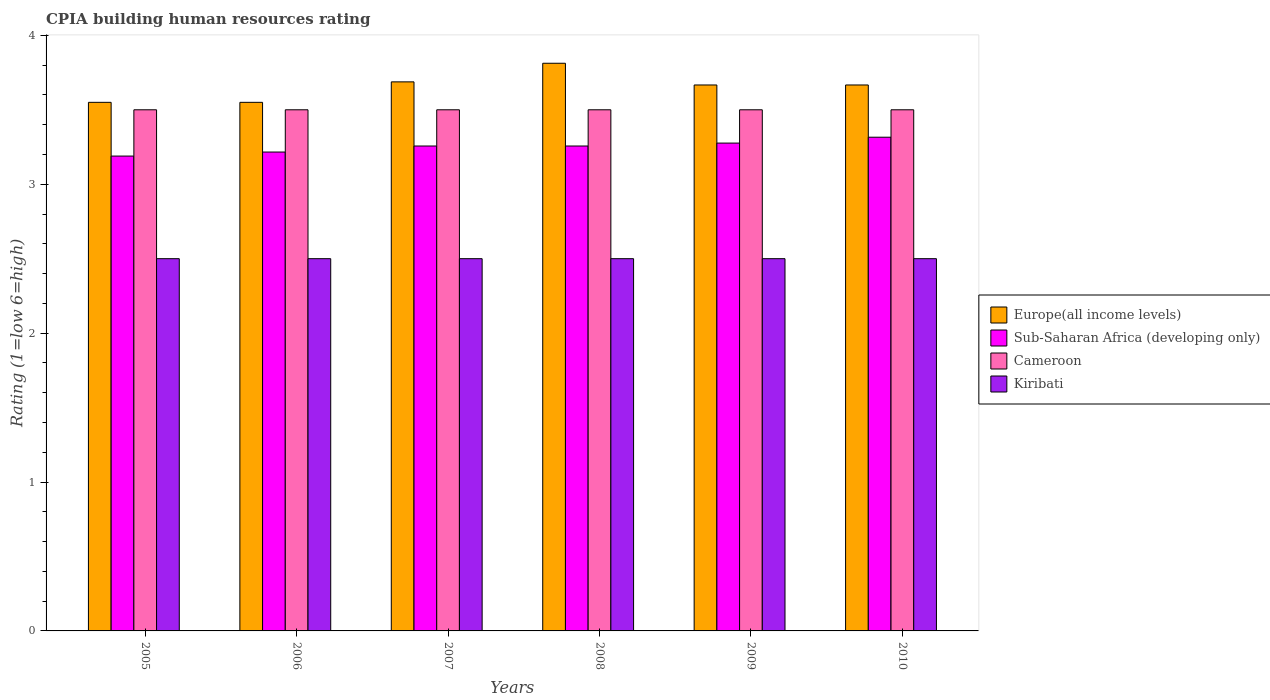How many groups of bars are there?
Give a very brief answer. 6. How many bars are there on the 1st tick from the left?
Your answer should be very brief. 4. What is the label of the 1st group of bars from the left?
Your answer should be compact. 2005. In how many cases, is the number of bars for a given year not equal to the number of legend labels?
Your answer should be compact. 0. Across all years, what is the maximum CPIA rating in Sub-Saharan Africa (developing only)?
Ensure brevity in your answer.  3.32. In which year was the CPIA rating in Europe(all income levels) minimum?
Keep it short and to the point. 2005. What is the total CPIA rating in Kiribati in the graph?
Give a very brief answer. 15. What is the difference between the CPIA rating in Kiribati in 2006 and that in 2007?
Provide a short and direct response. 0. What is the difference between the CPIA rating in Kiribati in 2008 and the CPIA rating in Sub-Saharan Africa (developing only) in 2007?
Your answer should be compact. -0.76. In the year 2008, what is the difference between the CPIA rating in Kiribati and CPIA rating in Sub-Saharan Africa (developing only)?
Your answer should be compact. -0.76. What is the ratio of the CPIA rating in Sub-Saharan Africa (developing only) in 2006 to that in 2007?
Ensure brevity in your answer.  0.99. Is the difference between the CPIA rating in Kiribati in 2006 and 2009 greater than the difference between the CPIA rating in Sub-Saharan Africa (developing only) in 2006 and 2009?
Provide a succinct answer. Yes. What is the difference between the highest and the second highest CPIA rating in Europe(all income levels)?
Your answer should be very brief. 0.12. What is the difference between the highest and the lowest CPIA rating in Europe(all income levels)?
Offer a very short reply. 0.26. Is the sum of the CPIA rating in Cameroon in 2008 and 2009 greater than the maximum CPIA rating in Europe(all income levels) across all years?
Offer a terse response. Yes. What does the 4th bar from the left in 2008 represents?
Make the answer very short. Kiribati. What does the 2nd bar from the right in 2008 represents?
Offer a very short reply. Cameroon. Is it the case that in every year, the sum of the CPIA rating in Europe(all income levels) and CPIA rating in Sub-Saharan Africa (developing only) is greater than the CPIA rating in Cameroon?
Provide a short and direct response. Yes. How many bars are there?
Your response must be concise. 24. Are all the bars in the graph horizontal?
Offer a terse response. No. How are the legend labels stacked?
Provide a short and direct response. Vertical. What is the title of the graph?
Offer a very short reply. CPIA building human resources rating. Does "Central African Republic" appear as one of the legend labels in the graph?
Offer a terse response. No. What is the label or title of the X-axis?
Provide a short and direct response. Years. What is the label or title of the Y-axis?
Offer a very short reply. Rating (1=low 6=high). What is the Rating (1=low 6=high) in Europe(all income levels) in 2005?
Ensure brevity in your answer.  3.55. What is the Rating (1=low 6=high) of Sub-Saharan Africa (developing only) in 2005?
Offer a very short reply. 3.19. What is the Rating (1=low 6=high) of Cameroon in 2005?
Your response must be concise. 3.5. What is the Rating (1=low 6=high) in Kiribati in 2005?
Give a very brief answer. 2.5. What is the Rating (1=low 6=high) of Europe(all income levels) in 2006?
Offer a very short reply. 3.55. What is the Rating (1=low 6=high) in Sub-Saharan Africa (developing only) in 2006?
Your response must be concise. 3.22. What is the Rating (1=low 6=high) in Kiribati in 2006?
Offer a very short reply. 2.5. What is the Rating (1=low 6=high) of Europe(all income levels) in 2007?
Your response must be concise. 3.69. What is the Rating (1=low 6=high) of Sub-Saharan Africa (developing only) in 2007?
Keep it short and to the point. 3.26. What is the Rating (1=low 6=high) of Europe(all income levels) in 2008?
Provide a succinct answer. 3.81. What is the Rating (1=low 6=high) in Sub-Saharan Africa (developing only) in 2008?
Your answer should be compact. 3.26. What is the Rating (1=low 6=high) in Europe(all income levels) in 2009?
Ensure brevity in your answer.  3.67. What is the Rating (1=low 6=high) in Sub-Saharan Africa (developing only) in 2009?
Your answer should be very brief. 3.28. What is the Rating (1=low 6=high) of Cameroon in 2009?
Your answer should be compact. 3.5. What is the Rating (1=low 6=high) of Europe(all income levels) in 2010?
Your answer should be compact. 3.67. What is the Rating (1=low 6=high) in Sub-Saharan Africa (developing only) in 2010?
Your answer should be compact. 3.32. Across all years, what is the maximum Rating (1=low 6=high) in Europe(all income levels)?
Your response must be concise. 3.81. Across all years, what is the maximum Rating (1=low 6=high) of Sub-Saharan Africa (developing only)?
Your response must be concise. 3.32. Across all years, what is the minimum Rating (1=low 6=high) in Europe(all income levels)?
Provide a succinct answer. 3.55. Across all years, what is the minimum Rating (1=low 6=high) of Sub-Saharan Africa (developing only)?
Your response must be concise. 3.19. Across all years, what is the minimum Rating (1=low 6=high) in Cameroon?
Ensure brevity in your answer.  3.5. What is the total Rating (1=low 6=high) in Europe(all income levels) in the graph?
Ensure brevity in your answer.  21.93. What is the total Rating (1=low 6=high) of Sub-Saharan Africa (developing only) in the graph?
Offer a very short reply. 19.51. What is the total Rating (1=low 6=high) in Cameroon in the graph?
Offer a terse response. 21. What is the difference between the Rating (1=low 6=high) in Europe(all income levels) in 2005 and that in 2006?
Offer a very short reply. 0. What is the difference between the Rating (1=low 6=high) of Sub-Saharan Africa (developing only) in 2005 and that in 2006?
Provide a succinct answer. -0.03. What is the difference between the Rating (1=low 6=high) of Kiribati in 2005 and that in 2006?
Provide a short and direct response. 0. What is the difference between the Rating (1=low 6=high) of Europe(all income levels) in 2005 and that in 2007?
Your answer should be very brief. -0.14. What is the difference between the Rating (1=low 6=high) in Sub-Saharan Africa (developing only) in 2005 and that in 2007?
Offer a very short reply. -0.07. What is the difference between the Rating (1=low 6=high) in Europe(all income levels) in 2005 and that in 2008?
Ensure brevity in your answer.  -0.26. What is the difference between the Rating (1=low 6=high) in Sub-Saharan Africa (developing only) in 2005 and that in 2008?
Ensure brevity in your answer.  -0.07. What is the difference between the Rating (1=low 6=high) of Cameroon in 2005 and that in 2008?
Provide a succinct answer. 0. What is the difference between the Rating (1=low 6=high) in Europe(all income levels) in 2005 and that in 2009?
Offer a very short reply. -0.12. What is the difference between the Rating (1=low 6=high) of Sub-Saharan Africa (developing only) in 2005 and that in 2009?
Give a very brief answer. -0.09. What is the difference between the Rating (1=low 6=high) of Cameroon in 2005 and that in 2009?
Your answer should be very brief. 0. What is the difference between the Rating (1=low 6=high) of Europe(all income levels) in 2005 and that in 2010?
Offer a very short reply. -0.12. What is the difference between the Rating (1=low 6=high) in Sub-Saharan Africa (developing only) in 2005 and that in 2010?
Give a very brief answer. -0.13. What is the difference between the Rating (1=low 6=high) of Europe(all income levels) in 2006 and that in 2007?
Your answer should be compact. -0.14. What is the difference between the Rating (1=low 6=high) in Sub-Saharan Africa (developing only) in 2006 and that in 2007?
Make the answer very short. -0.04. What is the difference between the Rating (1=low 6=high) of Europe(all income levels) in 2006 and that in 2008?
Provide a short and direct response. -0.26. What is the difference between the Rating (1=low 6=high) in Sub-Saharan Africa (developing only) in 2006 and that in 2008?
Make the answer very short. -0.04. What is the difference between the Rating (1=low 6=high) in Cameroon in 2006 and that in 2008?
Make the answer very short. 0. What is the difference between the Rating (1=low 6=high) of Kiribati in 2006 and that in 2008?
Your answer should be compact. 0. What is the difference between the Rating (1=low 6=high) in Europe(all income levels) in 2006 and that in 2009?
Keep it short and to the point. -0.12. What is the difference between the Rating (1=low 6=high) of Sub-Saharan Africa (developing only) in 2006 and that in 2009?
Your answer should be compact. -0.06. What is the difference between the Rating (1=low 6=high) of Cameroon in 2006 and that in 2009?
Your response must be concise. 0. What is the difference between the Rating (1=low 6=high) in Kiribati in 2006 and that in 2009?
Keep it short and to the point. 0. What is the difference between the Rating (1=low 6=high) of Europe(all income levels) in 2006 and that in 2010?
Offer a terse response. -0.12. What is the difference between the Rating (1=low 6=high) of Sub-Saharan Africa (developing only) in 2006 and that in 2010?
Ensure brevity in your answer.  -0.1. What is the difference between the Rating (1=low 6=high) in Europe(all income levels) in 2007 and that in 2008?
Make the answer very short. -0.12. What is the difference between the Rating (1=low 6=high) in Cameroon in 2007 and that in 2008?
Provide a succinct answer. 0. What is the difference between the Rating (1=low 6=high) of Kiribati in 2007 and that in 2008?
Your response must be concise. 0. What is the difference between the Rating (1=low 6=high) of Europe(all income levels) in 2007 and that in 2009?
Offer a terse response. 0.02. What is the difference between the Rating (1=low 6=high) in Sub-Saharan Africa (developing only) in 2007 and that in 2009?
Your response must be concise. -0.02. What is the difference between the Rating (1=low 6=high) of Cameroon in 2007 and that in 2009?
Your answer should be very brief. 0. What is the difference between the Rating (1=low 6=high) in Europe(all income levels) in 2007 and that in 2010?
Ensure brevity in your answer.  0.02. What is the difference between the Rating (1=low 6=high) in Sub-Saharan Africa (developing only) in 2007 and that in 2010?
Give a very brief answer. -0.06. What is the difference between the Rating (1=low 6=high) in Kiribati in 2007 and that in 2010?
Provide a short and direct response. 0. What is the difference between the Rating (1=low 6=high) in Europe(all income levels) in 2008 and that in 2009?
Provide a succinct answer. 0.15. What is the difference between the Rating (1=low 6=high) in Sub-Saharan Africa (developing only) in 2008 and that in 2009?
Provide a succinct answer. -0.02. What is the difference between the Rating (1=low 6=high) in Kiribati in 2008 and that in 2009?
Your answer should be very brief. 0. What is the difference between the Rating (1=low 6=high) of Europe(all income levels) in 2008 and that in 2010?
Ensure brevity in your answer.  0.15. What is the difference between the Rating (1=low 6=high) of Sub-Saharan Africa (developing only) in 2008 and that in 2010?
Offer a terse response. -0.06. What is the difference between the Rating (1=low 6=high) in Kiribati in 2008 and that in 2010?
Offer a very short reply. 0. What is the difference between the Rating (1=low 6=high) in Europe(all income levels) in 2009 and that in 2010?
Give a very brief answer. 0. What is the difference between the Rating (1=low 6=high) of Sub-Saharan Africa (developing only) in 2009 and that in 2010?
Keep it short and to the point. -0.04. What is the difference between the Rating (1=low 6=high) of Cameroon in 2009 and that in 2010?
Your answer should be very brief. 0. What is the difference between the Rating (1=low 6=high) of Europe(all income levels) in 2005 and the Rating (1=low 6=high) of Sub-Saharan Africa (developing only) in 2006?
Give a very brief answer. 0.33. What is the difference between the Rating (1=low 6=high) in Europe(all income levels) in 2005 and the Rating (1=low 6=high) in Cameroon in 2006?
Your answer should be very brief. 0.05. What is the difference between the Rating (1=low 6=high) of Sub-Saharan Africa (developing only) in 2005 and the Rating (1=low 6=high) of Cameroon in 2006?
Your answer should be compact. -0.31. What is the difference between the Rating (1=low 6=high) of Sub-Saharan Africa (developing only) in 2005 and the Rating (1=low 6=high) of Kiribati in 2006?
Your answer should be very brief. 0.69. What is the difference between the Rating (1=low 6=high) of Europe(all income levels) in 2005 and the Rating (1=low 6=high) of Sub-Saharan Africa (developing only) in 2007?
Offer a very short reply. 0.29. What is the difference between the Rating (1=low 6=high) in Sub-Saharan Africa (developing only) in 2005 and the Rating (1=low 6=high) in Cameroon in 2007?
Your answer should be compact. -0.31. What is the difference between the Rating (1=low 6=high) in Sub-Saharan Africa (developing only) in 2005 and the Rating (1=low 6=high) in Kiribati in 2007?
Make the answer very short. 0.69. What is the difference between the Rating (1=low 6=high) of Cameroon in 2005 and the Rating (1=low 6=high) of Kiribati in 2007?
Make the answer very short. 1. What is the difference between the Rating (1=low 6=high) of Europe(all income levels) in 2005 and the Rating (1=low 6=high) of Sub-Saharan Africa (developing only) in 2008?
Give a very brief answer. 0.29. What is the difference between the Rating (1=low 6=high) in Europe(all income levels) in 2005 and the Rating (1=low 6=high) in Cameroon in 2008?
Offer a very short reply. 0.05. What is the difference between the Rating (1=low 6=high) of Sub-Saharan Africa (developing only) in 2005 and the Rating (1=low 6=high) of Cameroon in 2008?
Make the answer very short. -0.31. What is the difference between the Rating (1=low 6=high) of Sub-Saharan Africa (developing only) in 2005 and the Rating (1=low 6=high) of Kiribati in 2008?
Provide a succinct answer. 0.69. What is the difference between the Rating (1=low 6=high) of Cameroon in 2005 and the Rating (1=low 6=high) of Kiribati in 2008?
Give a very brief answer. 1. What is the difference between the Rating (1=low 6=high) in Europe(all income levels) in 2005 and the Rating (1=low 6=high) in Sub-Saharan Africa (developing only) in 2009?
Your answer should be very brief. 0.27. What is the difference between the Rating (1=low 6=high) of Europe(all income levels) in 2005 and the Rating (1=low 6=high) of Kiribati in 2009?
Provide a short and direct response. 1.05. What is the difference between the Rating (1=low 6=high) of Sub-Saharan Africa (developing only) in 2005 and the Rating (1=low 6=high) of Cameroon in 2009?
Offer a very short reply. -0.31. What is the difference between the Rating (1=low 6=high) in Sub-Saharan Africa (developing only) in 2005 and the Rating (1=low 6=high) in Kiribati in 2009?
Offer a terse response. 0.69. What is the difference between the Rating (1=low 6=high) of Cameroon in 2005 and the Rating (1=low 6=high) of Kiribati in 2009?
Ensure brevity in your answer.  1. What is the difference between the Rating (1=low 6=high) in Europe(all income levels) in 2005 and the Rating (1=low 6=high) in Sub-Saharan Africa (developing only) in 2010?
Make the answer very short. 0.23. What is the difference between the Rating (1=low 6=high) of Sub-Saharan Africa (developing only) in 2005 and the Rating (1=low 6=high) of Cameroon in 2010?
Ensure brevity in your answer.  -0.31. What is the difference between the Rating (1=low 6=high) of Sub-Saharan Africa (developing only) in 2005 and the Rating (1=low 6=high) of Kiribati in 2010?
Your response must be concise. 0.69. What is the difference between the Rating (1=low 6=high) of Europe(all income levels) in 2006 and the Rating (1=low 6=high) of Sub-Saharan Africa (developing only) in 2007?
Keep it short and to the point. 0.29. What is the difference between the Rating (1=low 6=high) in Europe(all income levels) in 2006 and the Rating (1=low 6=high) in Kiribati in 2007?
Your answer should be very brief. 1.05. What is the difference between the Rating (1=low 6=high) in Sub-Saharan Africa (developing only) in 2006 and the Rating (1=low 6=high) in Cameroon in 2007?
Offer a terse response. -0.28. What is the difference between the Rating (1=low 6=high) in Sub-Saharan Africa (developing only) in 2006 and the Rating (1=low 6=high) in Kiribati in 2007?
Your response must be concise. 0.72. What is the difference between the Rating (1=low 6=high) in Europe(all income levels) in 2006 and the Rating (1=low 6=high) in Sub-Saharan Africa (developing only) in 2008?
Your response must be concise. 0.29. What is the difference between the Rating (1=low 6=high) in Europe(all income levels) in 2006 and the Rating (1=low 6=high) in Cameroon in 2008?
Keep it short and to the point. 0.05. What is the difference between the Rating (1=low 6=high) in Europe(all income levels) in 2006 and the Rating (1=low 6=high) in Kiribati in 2008?
Provide a succinct answer. 1.05. What is the difference between the Rating (1=low 6=high) in Sub-Saharan Africa (developing only) in 2006 and the Rating (1=low 6=high) in Cameroon in 2008?
Provide a succinct answer. -0.28. What is the difference between the Rating (1=low 6=high) of Sub-Saharan Africa (developing only) in 2006 and the Rating (1=low 6=high) of Kiribati in 2008?
Offer a terse response. 0.72. What is the difference between the Rating (1=low 6=high) in Cameroon in 2006 and the Rating (1=low 6=high) in Kiribati in 2008?
Give a very brief answer. 1. What is the difference between the Rating (1=low 6=high) in Europe(all income levels) in 2006 and the Rating (1=low 6=high) in Sub-Saharan Africa (developing only) in 2009?
Your answer should be compact. 0.27. What is the difference between the Rating (1=low 6=high) of Sub-Saharan Africa (developing only) in 2006 and the Rating (1=low 6=high) of Cameroon in 2009?
Make the answer very short. -0.28. What is the difference between the Rating (1=low 6=high) of Sub-Saharan Africa (developing only) in 2006 and the Rating (1=low 6=high) of Kiribati in 2009?
Give a very brief answer. 0.72. What is the difference between the Rating (1=low 6=high) in Europe(all income levels) in 2006 and the Rating (1=low 6=high) in Sub-Saharan Africa (developing only) in 2010?
Your response must be concise. 0.23. What is the difference between the Rating (1=low 6=high) in Sub-Saharan Africa (developing only) in 2006 and the Rating (1=low 6=high) in Cameroon in 2010?
Offer a terse response. -0.28. What is the difference between the Rating (1=low 6=high) of Sub-Saharan Africa (developing only) in 2006 and the Rating (1=low 6=high) of Kiribati in 2010?
Your answer should be very brief. 0.72. What is the difference between the Rating (1=low 6=high) of Europe(all income levels) in 2007 and the Rating (1=low 6=high) of Sub-Saharan Africa (developing only) in 2008?
Make the answer very short. 0.43. What is the difference between the Rating (1=low 6=high) in Europe(all income levels) in 2007 and the Rating (1=low 6=high) in Cameroon in 2008?
Provide a short and direct response. 0.19. What is the difference between the Rating (1=low 6=high) of Europe(all income levels) in 2007 and the Rating (1=low 6=high) of Kiribati in 2008?
Ensure brevity in your answer.  1.19. What is the difference between the Rating (1=low 6=high) in Sub-Saharan Africa (developing only) in 2007 and the Rating (1=low 6=high) in Cameroon in 2008?
Ensure brevity in your answer.  -0.24. What is the difference between the Rating (1=low 6=high) of Sub-Saharan Africa (developing only) in 2007 and the Rating (1=low 6=high) of Kiribati in 2008?
Your answer should be very brief. 0.76. What is the difference between the Rating (1=low 6=high) in Europe(all income levels) in 2007 and the Rating (1=low 6=high) in Sub-Saharan Africa (developing only) in 2009?
Provide a succinct answer. 0.41. What is the difference between the Rating (1=low 6=high) in Europe(all income levels) in 2007 and the Rating (1=low 6=high) in Cameroon in 2009?
Your response must be concise. 0.19. What is the difference between the Rating (1=low 6=high) of Europe(all income levels) in 2007 and the Rating (1=low 6=high) of Kiribati in 2009?
Your response must be concise. 1.19. What is the difference between the Rating (1=low 6=high) in Sub-Saharan Africa (developing only) in 2007 and the Rating (1=low 6=high) in Cameroon in 2009?
Ensure brevity in your answer.  -0.24. What is the difference between the Rating (1=low 6=high) of Sub-Saharan Africa (developing only) in 2007 and the Rating (1=low 6=high) of Kiribati in 2009?
Your answer should be very brief. 0.76. What is the difference between the Rating (1=low 6=high) in Cameroon in 2007 and the Rating (1=low 6=high) in Kiribati in 2009?
Your answer should be compact. 1. What is the difference between the Rating (1=low 6=high) of Europe(all income levels) in 2007 and the Rating (1=low 6=high) of Sub-Saharan Africa (developing only) in 2010?
Your response must be concise. 0.37. What is the difference between the Rating (1=low 6=high) in Europe(all income levels) in 2007 and the Rating (1=low 6=high) in Cameroon in 2010?
Your response must be concise. 0.19. What is the difference between the Rating (1=low 6=high) in Europe(all income levels) in 2007 and the Rating (1=low 6=high) in Kiribati in 2010?
Your answer should be compact. 1.19. What is the difference between the Rating (1=low 6=high) of Sub-Saharan Africa (developing only) in 2007 and the Rating (1=low 6=high) of Cameroon in 2010?
Give a very brief answer. -0.24. What is the difference between the Rating (1=low 6=high) of Sub-Saharan Africa (developing only) in 2007 and the Rating (1=low 6=high) of Kiribati in 2010?
Provide a short and direct response. 0.76. What is the difference between the Rating (1=low 6=high) of Cameroon in 2007 and the Rating (1=low 6=high) of Kiribati in 2010?
Provide a succinct answer. 1. What is the difference between the Rating (1=low 6=high) in Europe(all income levels) in 2008 and the Rating (1=low 6=high) in Sub-Saharan Africa (developing only) in 2009?
Offer a very short reply. 0.54. What is the difference between the Rating (1=low 6=high) in Europe(all income levels) in 2008 and the Rating (1=low 6=high) in Cameroon in 2009?
Offer a very short reply. 0.31. What is the difference between the Rating (1=low 6=high) in Europe(all income levels) in 2008 and the Rating (1=low 6=high) in Kiribati in 2009?
Your answer should be very brief. 1.31. What is the difference between the Rating (1=low 6=high) in Sub-Saharan Africa (developing only) in 2008 and the Rating (1=low 6=high) in Cameroon in 2009?
Ensure brevity in your answer.  -0.24. What is the difference between the Rating (1=low 6=high) in Sub-Saharan Africa (developing only) in 2008 and the Rating (1=low 6=high) in Kiribati in 2009?
Your answer should be compact. 0.76. What is the difference between the Rating (1=low 6=high) in Europe(all income levels) in 2008 and the Rating (1=low 6=high) in Sub-Saharan Africa (developing only) in 2010?
Provide a short and direct response. 0.5. What is the difference between the Rating (1=low 6=high) in Europe(all income levels) in 2008 and the Rating (1=low 6=high) in Cameroon in 2010?
Your response must be concise. 0.31. What is the difference between the Rating (1=low 6=high) of Europe(all income levels) in 2008 and the Rating (1=low 6=high) of Kiribati in 2010?
Provide a succinct answer. 1.31. What is the difference between the Rating (1=low 6=high) of Sub-Saharan Africa (developing only) in 2008 and the Rating (1=low 6=high) of Cameroon in 2010?
Your answer should be very brief. -0.24. What is the difference between the Rating (1=low 6=high) in Sub-Saharan Africa (developing only) in 2008 and the Rating (1=low 6=high) in Kiribati in 2010?
Keep it short and to the point. 0.76. What is the difference between the Rating (1=low 6=high) of Europe(all income levels) in 2009 and the Rating (1=low 6=high) of Sub-Saharan Africa (developing only) in 2010?
Keep it short and to the point. 0.35. What is the difference between the Rating (1=low 6=high) in Europe(all income levels) in 2009 and the Rating (1=low 6=high) in Kiribati in 2010?
Your response must be concise. 1.17. What is the difference between the Rating (1=low 6=high) in Sub-Saharan Africa (developing only) in 2009 and the Rating (1=low 6=high) in Cameroon in 2010?
Give a very brief answer. -0.22. What is the difference between the Rating (1=low 6=high) in Sub-Saharan Africa (developing only) in 2009 and the Rating (1=low 6=high) in Kiribati in 2010?
Offer a terse response. 0.78. What is the difference between the Rating (1=low 6=high) of Cameroon in 2009 and the Rating (1=low 6=high) of Kiribati in 2010?
Make the answer very short. 1. What is the average Rating (1=low 6=high) of Europe(all income levels) per year?
Ensure brevity in your answer.  3.66. What is the average Rating (1=low 6=high) in Sub-Saharan Africa (developing only) per year?
Ensure brevity in your answer.  3.25. What is the average Rating (1=low 6=high) of Cameroon per year?
Make the answer very short. 3.5. What is the average Rating (1=low 6=high) of Kiribati per year?
Give a very brief answer. 2.5. In the year 2005, what is the difference between the Rating (1=low 6=high) in Europe(all income levels) and Rating (1=low 6=high) in Sub-Saharan Africa (developing only)?
Make the answer very short. 0.36. In the year 2005, what is the difference between the Rating (1=low 6=high) in Europe(all income levels) and Rating (1=low 6=high) in Cameroon?
Provide a succinct answer. 0.05. In the year 2005, what is the difference between the Rating (1=low 6=high) of Europe(all income levels) and Rating (1=low 6=high) of Kiribati?
Ensure brevity in your answer.  1.05. In the year 2005, what is the difference between the Rating (1=low 6=high) of Sub-Saharan Africa (developing only) and Rating (1=low 6=high) of Cameroon?
Provide a succinct answer. -0.31. In the year 2005, what is the difference between the Rating (1=low 6=high) of Sub-Saharan Africa (developing only) and Rating (1=low 6=high) of Kiribati?
Your answer should be compact. 0.69. In the year 2006, what is the difference between the Rating (1=low 6=high) of Europe(all income levels) and Rating (1=low 6=high) of Sub-Saharan Africa (developing only)?
Your answer should be very brief. 0.33. In the year 2006, what is the difference between the Rating (1=low 6=high) of Europe(all income levels) and Rating (1=low 6=high) of Cameroon?
Your answer should be compact. 0.05. In the year 2006, what is the difference between the Rating (1=low 6=high) in Europe(all income levels) and Rating (1=low 6=high) in Kiribati?
Your response must be concise. 1.05. In the year 2006, what is the difference between the Rating (1=low 6=high) of Sub-Saharan Africa (developing only) and Rating (1=low 6=high) of Cameroon?
Provide a short and direct response. -0.28. In the year 2006, what is the difference between the Rating (1=low 6=high) in Sub-Saharan Africa (developing only) and Rating (1=low 6=high) in Kiribati?
Your answer should be compact. 0.72. In the year 2006, what is the difference between the Rating (1=low 6=high) in Cameroon and Rating (1=low 6=high) in Kiribati?
Ensure brevity in your answer.  1. In the year 2007, what is the difference between the Rating (1=low 6=high) in Europe(all income levels) and Rating (1=low 6=high) in Sub-Saharan Africa (developing only)?
Give a very brief answer. 0.43. In the year 2007, what is the difference between the Rating (1=low 6=high) of Europe(all income levels) and Rating (1=low 6=high) of Cameroon?
Keep it short and to the point. 0.19. In the year 2007, what is the difference between the Rating (1=low 6=high) of Europe(all income levels) and Rating (1=low 6=high) of Kiribati?
Offer a terse response. 1.19. In the year 2007, what is the difference between the Rating (1=low 6=high) in Sub-Saharan Africa (developing only) and Rating (1=low 6=high) in Cameroon?
Give a very brief answer. -0.24. In the year 2007, what is the difference between the Rating (1=low 6=high) of Sub-Saharan Africa (developing only) and Rating (1=low 6=high) of Kiribati?
Offer a very short reply. 0.76. In the year 2007, what is the difference between the Rating (1=low 6=high) of Cameroon and Rating (1=low 6=high) of Kiribati?
Ensure brevity in your answer.  1. In the year 2008, what is the difference between the Rating (1=low 6=high) of Europe(all income levels) and Rating (1=low 6=high) of Sub-Saharan Africa (developing only)?
Your answer should be very brief. 0.56. In the year 2008, what is the difference between the Rating (1=low 6=high) in Europe(all income levels) and Rating (1=low 6=high) in Cameroon?
Ensure brevity in your answer.  0.31. In the year 2008, what is the difference between the Rating (1=low 6=high) in Europe(all income levels) and Rating (1=low 6=high) in Kiribati?
Provide a short and direct response. 1.31. In the year 2008, what is the difference between the Rating (1=low 6=high) in Sub-Saharan Africa (developing only) and Rating (1=low 6=high) in Cameroon?
Offer a terse response. -0.24. In the year 2008, what is the difference between the Rating (1=low 6=high) of Sub-Saharan Africa (developing only) and Rating (1=low 6=high) of Kiribati?
Offer a terse response. 0.76. In the year 2009, what is the difference between the Rating (1=low 6=high) in Europe(all income levels) and Rating (1=low 6=high) in Sub-Saharan Africa (developing only)?
Make the answer very short. 0.39. In the year 2009, what is the difference between the Rating (1=low 6=high) of Europe(all income levels) and Rating (1=low 6=high) of Kiribati?
Give a very brief answer. 1.17. In the year 2009, what is the difference between the Rating (1=low 6=high) in Sub-Saharan Africa (developing only) and Rating (1=low 6=high) in Cameroon?
Provide a short and direct response. -0.22. In the year 2009, what is the difference between the Rating (1=low 6=high) of Sub-Saharan Africa (developing only) and Rating (1=low 6=high) of Kiribati?
Offer a very short reply. 0.78. In the year 2009, what is the difference between the Rating (1=low 6=high) in Cameroon and Rating (1=low 6=high) in Kiribati?
Ensure brevity in your answer.  1. In the year 2010, what is the difference between the Rating (1=low 6=high) of Europe(all income levels) and Rating (1=low 6=high) of Sub-Saharan Africa (developing only)?
Your answer should be compact. 0.35. In the year 2010, what is the difference between the Rating (1=low 6=high) of Sub-Saharan Africa (developing only) and Rating (1=low 6=high) of Cameroon?
Give a very brief answer. -0.18. In the year 2010, what is the difference between the Rating (1=low 6=high) of Sub-Saharan Africa (developing only) and Rating (1=low 6=high) of Kiribati?
Your answer should be very brief. 0.82. What is the ratio of the Rating (1=low 6=high) of Europe(all income levels) in 2005 to that in 2006?
Your answer should be very brief. 1. What is the ratio of the Rating (1=low 6=high) of Sub-Saharan Africa (developing only) in 2005 to that in 2006?
Make the answer very short. 0.99. What is the ratio of the Rating (1=low 6=high) of Kiribati in 2005 to that in 2006?
Your answer should be very brief. 1. What is the ratio of the Rating (1=low 6=high) of Europe(all income levels) in 2005 to that in 2007?
Ensure brevity in your answer.  0.96. What is the ratio of the Rating (1=low 6=high) in Sub-Saharan Africa (developing only) in 2005 to that in 2007?
Keep it short and to the point. 0.98. What is the ratio of the Rating (1=low 6=high) of Europe(all income levels) in 2005 to that in 2008?
Offer a terse response. 0.93. What is the ratio of the Rating (1=low 6=high) in Sub-Saharan Africa (developing only) in 2005 to that in 2008?
Ensure brevity in your answer.  0.98. What is the ratio of the Rating (1=low 6=high) in Kiribati in 2005 to that in 2008?
Your answer should be very brief. 1. What is the ratio of the Rating (1=low 6=high) of Europe(all income levels) in 2005 to that in 2009?
Give a very brief answer. 0.97. What is the ratio of the Rating (1=low 6=high) of Sub-Saharan Africa (developing only) in 2005 to that in 2009?
Make the answer very short. 0.97. What is the ratio of the Rating (1=low 6=high) of Kiribati in 2005 to that in 2009?
Offer a terse response. 1. What is the ratio of the Rating (1=low 6=high) in Europe(all income levels) in 2005 to that in 2010?
Provide a succinct answer. 0.97. What is the ratio of the Rating (1=low 6=high) in Sub-Saharan Africa (developing only) in 2005 to that in 2010?
Your response must be concise. 0.96. What is the ratio of the Rating (1=low 6=high) of Europe(all income levels) in 2006 to that in 2007?
Keep it short and to the point. 0.96. What is the ratio of the Rating (1=low 6=high) of Sub-Saharan Africa (developing only) in 2006 to that in 2007?
Keep it short and to the point. 0.99. What is the ratio of the Rating (1=low 6=high) of Cameroon in 2006 to that in 2007?
Ensure brevity in your answer.  1. What is the ratio of the Rating (1=low 6=high) in Europe(all income levels) in 2006 to that in 2008?
Your response must be concise. 0.93. What is the ratio of the Rating (1=low 6=high) of Sub-Saharan Africa (developing only) in 2006 to that in 2008?
Provide a succinct answer. 0.99. What is the ratio of the Rating (1=low 6=high) in Cameroon in 2006 to that in 2008?
Your answer should be compact. 1. What is the ratio of the Rating (1=low 6=high) in Europe(all income levels) in 2006 to that in 2009?
Ensure brevity in your answer.  0.97. What is the ratio of the Rating (1=low 6=high) of Sub-Saharan Africa (developing only) in 2006 to that in 2009?
Offer a very short reply. 0.98. What is the ratio of the Rating (1=low 6=high) of Europe(all income levels) in 2006 to that in 2010?
Your answer should be very brief. 0.97. What is the ratio of the Rating (1=low 6=high) of Sub-Saharan Africa (developing only) in 2006 to that in 2010?
Provide a succinct answer. 0.97. What is the ratio of the Rating (1=low 6=high) of Cameroon in 2006 to that in 2010?
Your response must be concise. 1. What is the ratio of the Rating (1=low 6=high) in Europe(all income levels) in 2007 to that in 2008?
Your answer should be compact. 0.97. What is the ratio of the Rating (1=low 6=high) in Sub-Saharan Africa (developing only) in 2007 to that in 2008?
Offer a very short reply. 1. What is the ratio of the Rating (1=low 6=high) in Cameroon in 2007 to that in 2009?
Provide a succinct answer. 1. What is the ratio of the Rating (1=low 6=high) in Kiribati in 2007 to that in 2009?
Keep it short and to the point. 1. What is the ratio of the Rating (1=low 6=high) in Europe(all income levels) in 2007 to that in 2010?
Your answer should be compact. 1.01. What is the ratio of the Rating (1=low 6=high) in Sub-Saharan Africa (developing only) in 2007 to that in 2010?
Make the answer very short. 0.98. What is the ratio of the Rating (1=low 6=high) in Europe(all income levels) in 2008 to that in 2009?
Offer a very short reply. 1.04. What is the ratio of the Rating (1=low 6=high) of Cameroon in 2008 to that in 2009?
Give a very brief answer. 1. What is the ratio of the Rating (1=low 6=high) in Europe(all income levels) in 2008 to that in 2010?
Your answer should be very brief. 1.04. What is the ratio of the Rating (1=low 6=high) of Sub-Saharan Africa (developing only) in 2008 to that in 2010?
Keep it short and to the point. 0.98. What is the ratio of the Rating (1=low 6=high) of Cameroon in 2008 to that in 2010?
Offer a terse response. 1. What is the ratio of the Rating (1=low 6=high) of Cameroon in 2009 to that in 2010?
Give a very brief answer. 1. What is the ratio of the Rating (1=low 6=high) of Kiribati in 2009 to that in 2010?
Offer a terse response. 1. What is the difference between the highest and the second highest Rating (1=low 6=high) in Sub-Saharan Africa (developing only)?
Ensure brevity in your answer.  0.04. What is the difference between the highest and the second highest Rating (1=low 6=high) of Cameroon?
Provide a succinct answer. 0. What is the difference between the highest and the second highest Rating (1=low 6=high) in Kiribati?
Your answer should be compact. 0. What is the difference between the highest and the lowest Rating (1=low 6=high) of Europe(all income levels)?
Offer a very short reply. 0.26. What is the difference between the highest and the lowest Rating (1=low 6=high) in Sub-Saharan Africa (developing only)?
Offer a very short reply. 0.13. What is the difference between the highest and the lowest Rating (1=low 6=high) in Cameroon?
Offer a very short reply. 0. What is the difference between the highest and the lowest Rating (1=low 6=high) of Kiribati?
Your answer should be compact. 0. 